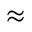Convert formula to latex. <formula><loc_0><loc_0><loc_500><loc_500>\approx</formula> 